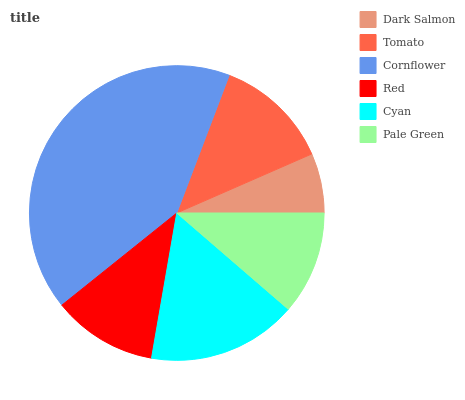Is Dark Salmon the minimum?
Answer yes or no. Yes. Is Cornflower the maximum?
Answer yes or no. Yes. Is Tomato the minimum?
Answer yes or no. No. Is Tomato the maximum?
Answer yes or no. No. Is Tomato greater than Dark Salmon?
Answer yes or no. Yes. Is Dark Salmon less than Tomato?
Answer yes or no. Yes. Is Dark Salmon greater than Tomato?
Answer yes or no. No. Is Tomato less than Dark Salmon?
Answer yes or no. No. Is Tomato the high median?
Answer yes or no. Yes. Is Red the low median?
Answer yes or no. Yes. Is Pale Green the high median?
Answer yes or no. No. Is Dark Salmon the low median?
Answer yes or no. No. 